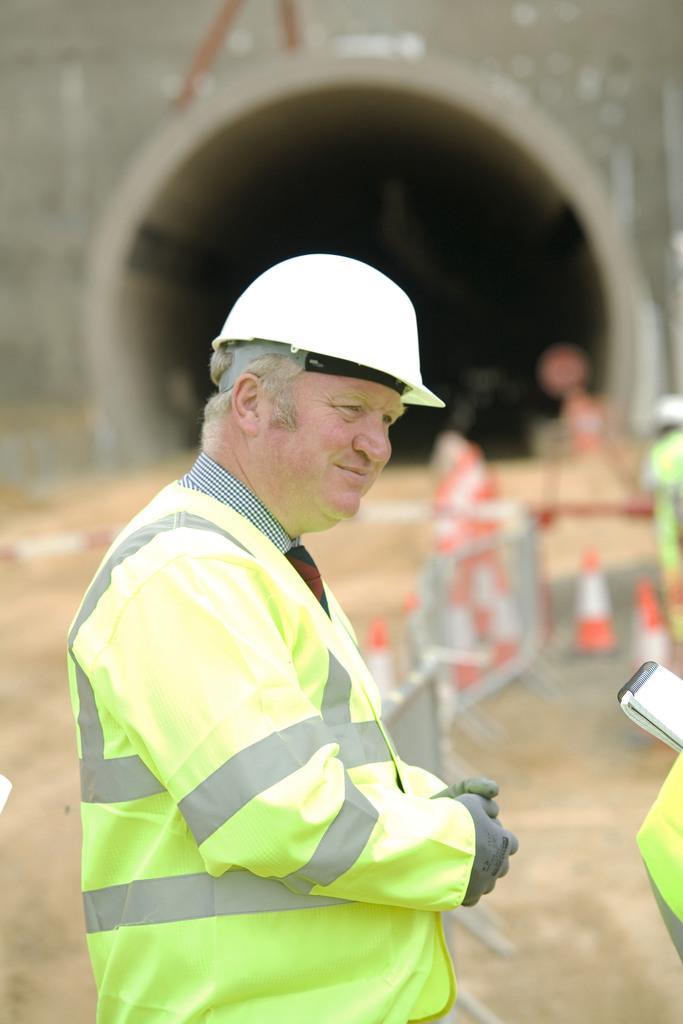Please provide a concise description of this image. In the foreground of the picture there is a man wearing a helmet. The background is blurred. In the background there are indicators, mud and a tunnel. On the right there are people and a book. 